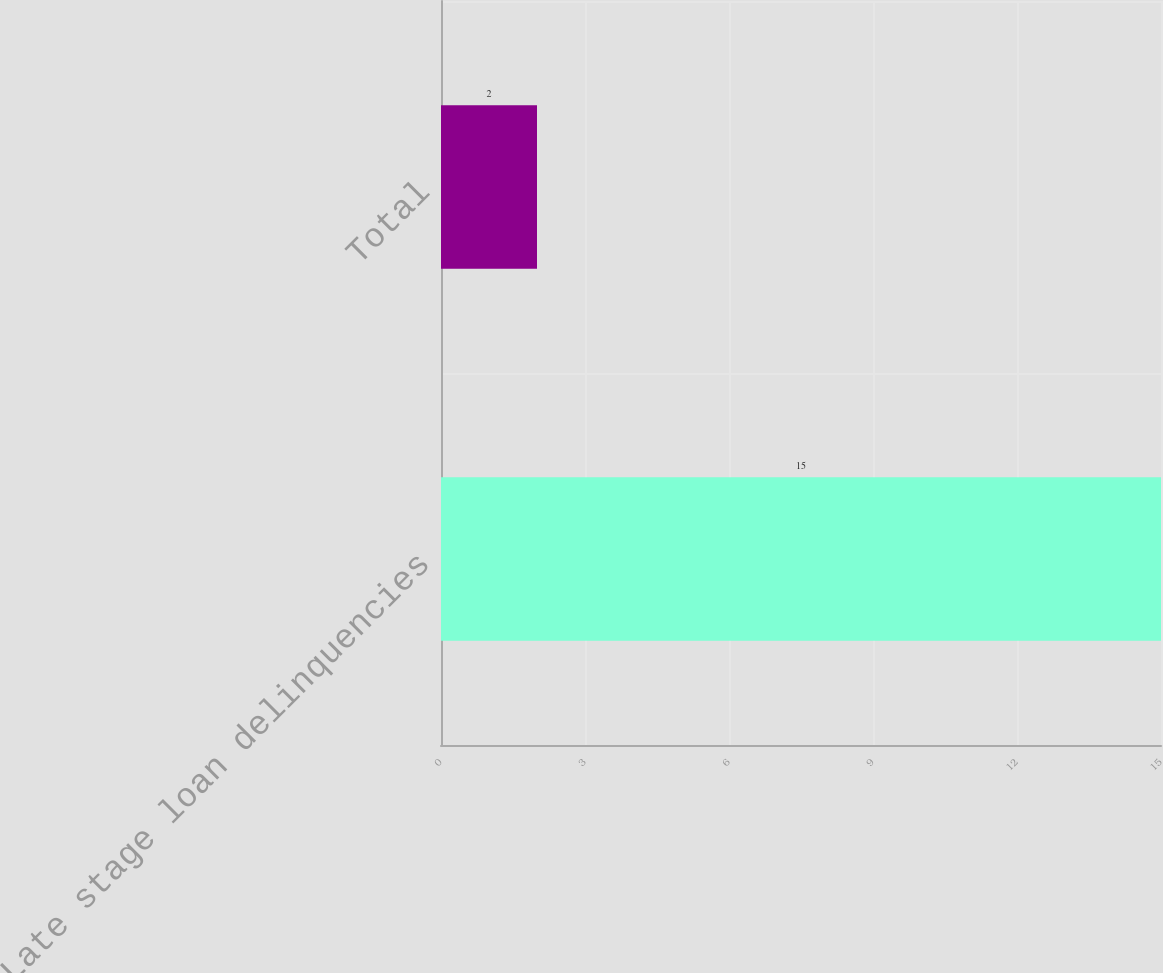<chart> <loc_0><loc_0><loc_500><loc_500><bar_chart><fcel>Late stage loan delinquencies<fcel>Total<nl><fcel>15<fcel>2<nl></chart> 